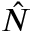Convert formula to latex. <formula><loc_0><loc_0><loc_500><loc_500>\hat { N }</formula> 